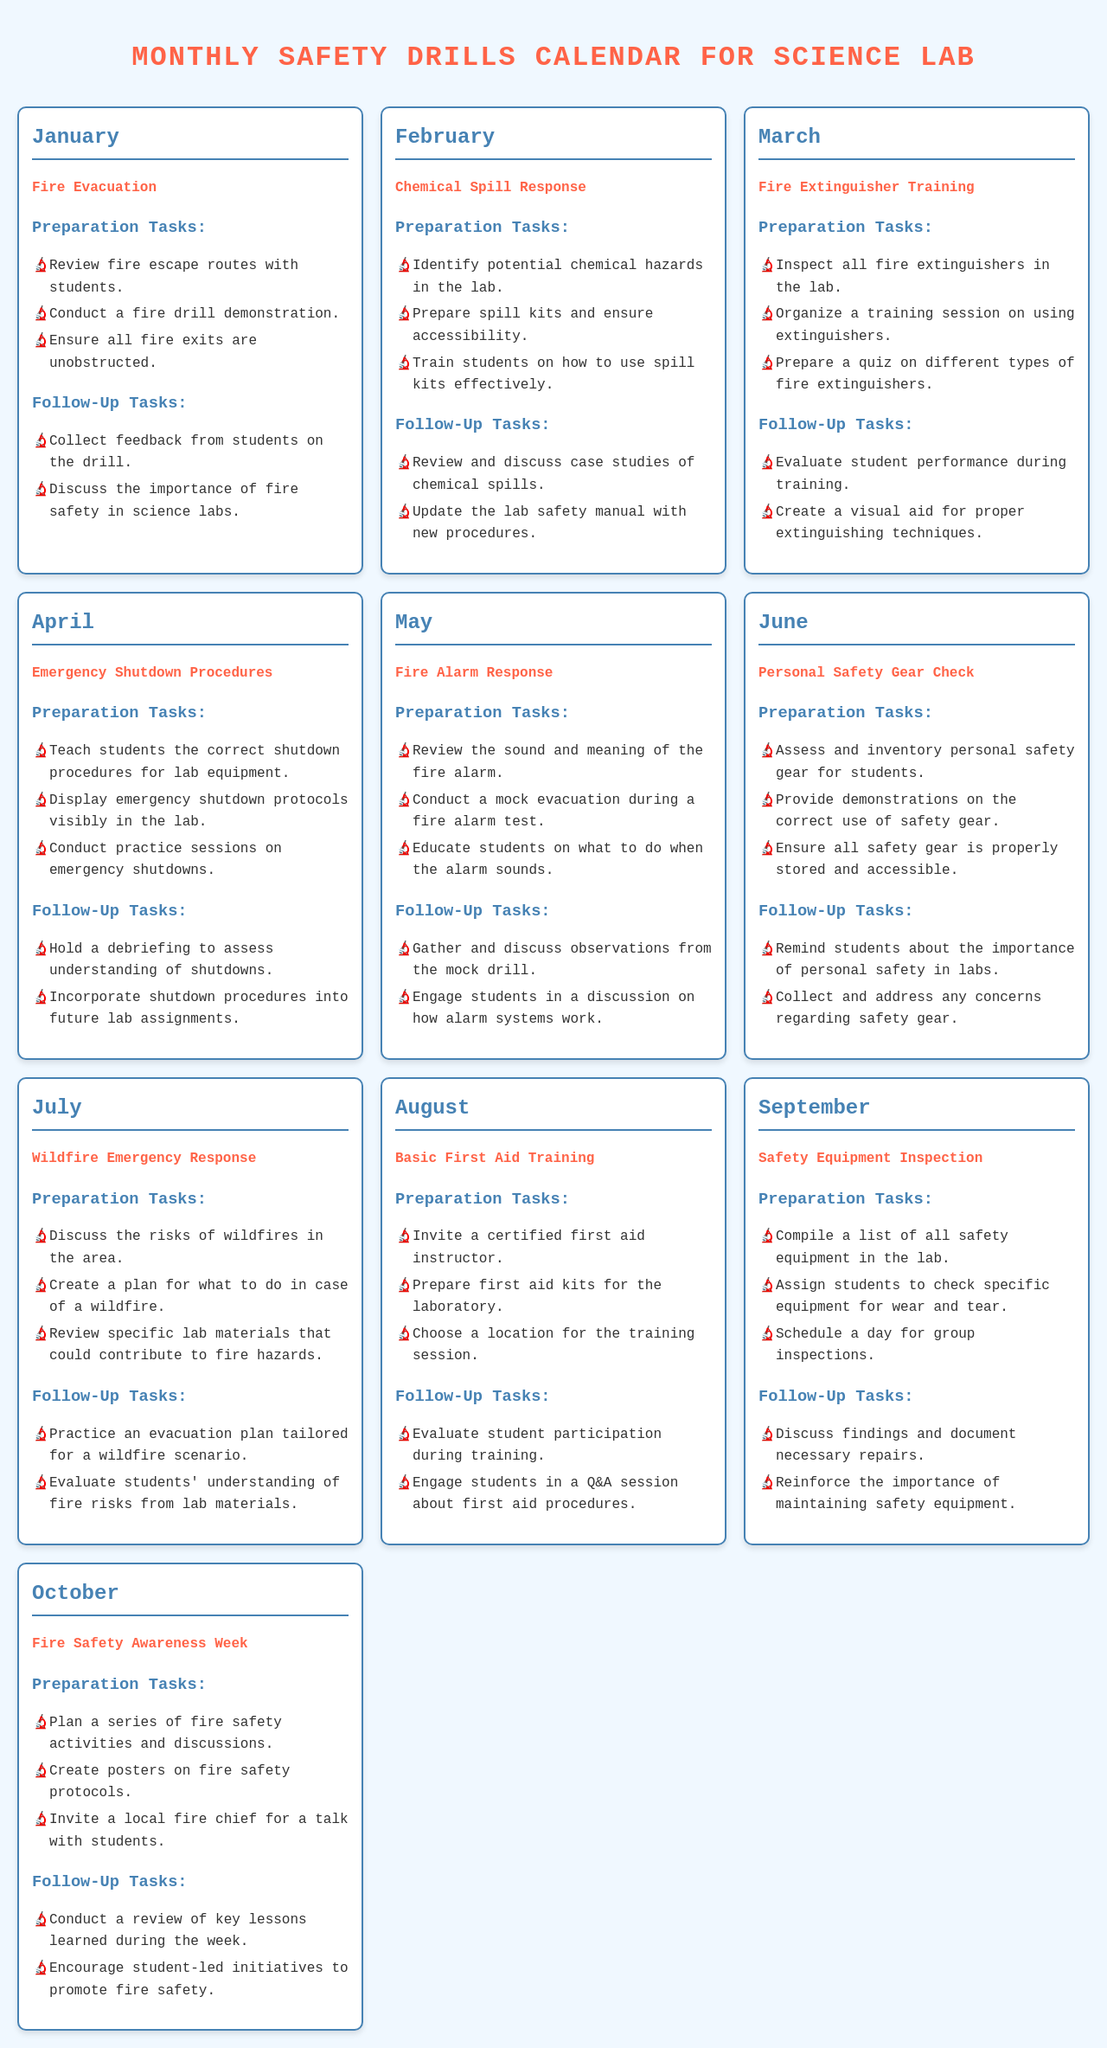What type of drill is scheduled for January? January's drill is focused on fire evacuation safety, as indicated in the document.
Answer: Fire Evacuation What tasks are included in the follow-up for the February drill? The follow-up for February includes reviewing case studies of chemical spills and updating the lab safety manual, as stated in the document.
Answer: Review and discuss case studies of chemical spills; Update the lab safety manual with new procedures How many drills are planned for the month of March? March has one drill scheduled, which is focused on fire extinguisher training according to the document.
Answer: One What essential preparation task is listed for the July drill? In July, an important preparation task involves discussing the risks of wildfires, as outlined in the document.
Answer: Discuss the risks of wildfires in the area What types of activities are planned for October's Fire Safety Awareness Week? October's activities include planning fire safety activities and inviting a local fire chief, as mentioned in the document.
Answer: A series of fire safety activities; Invitations to a local fire chief for a talk What is the main focus of the follow-up tasks in June? For June's follow-up, students are reminded about the importance of personal safety in labs and collect concerns regarding safety gear, as described in the document.
Answer: Remind students about the importance of personal safety in labs; Collect and address concerns regarding safety gear 